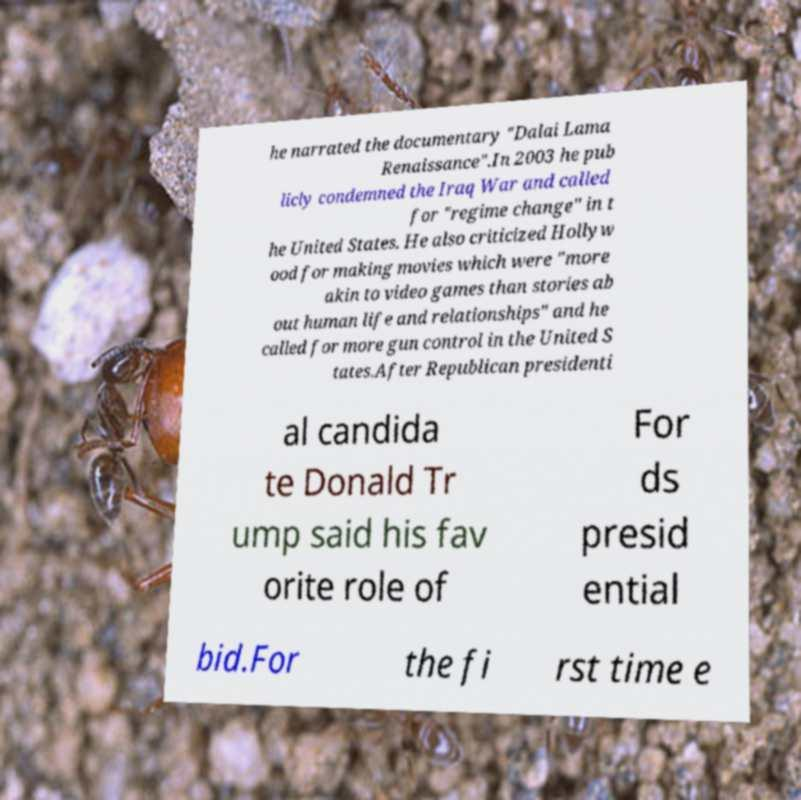There's text embedded in this image that I need extracted. Can you transcribe it verbatim? he narrated the documentary "Dalai Lama Renaissance".In 2003 he pub licly condemned the Iraq War and called for "regime change" in t he United States. He also criticized Hollyw ood for making movies which were "more akin to video games than stories ab out human life and relationships" and he called for more gun control in the United S tates.After Republican presidenti al candida te Donald Tr ump said his fav orite role of For ds presid ential bid.For the fi rst time e 